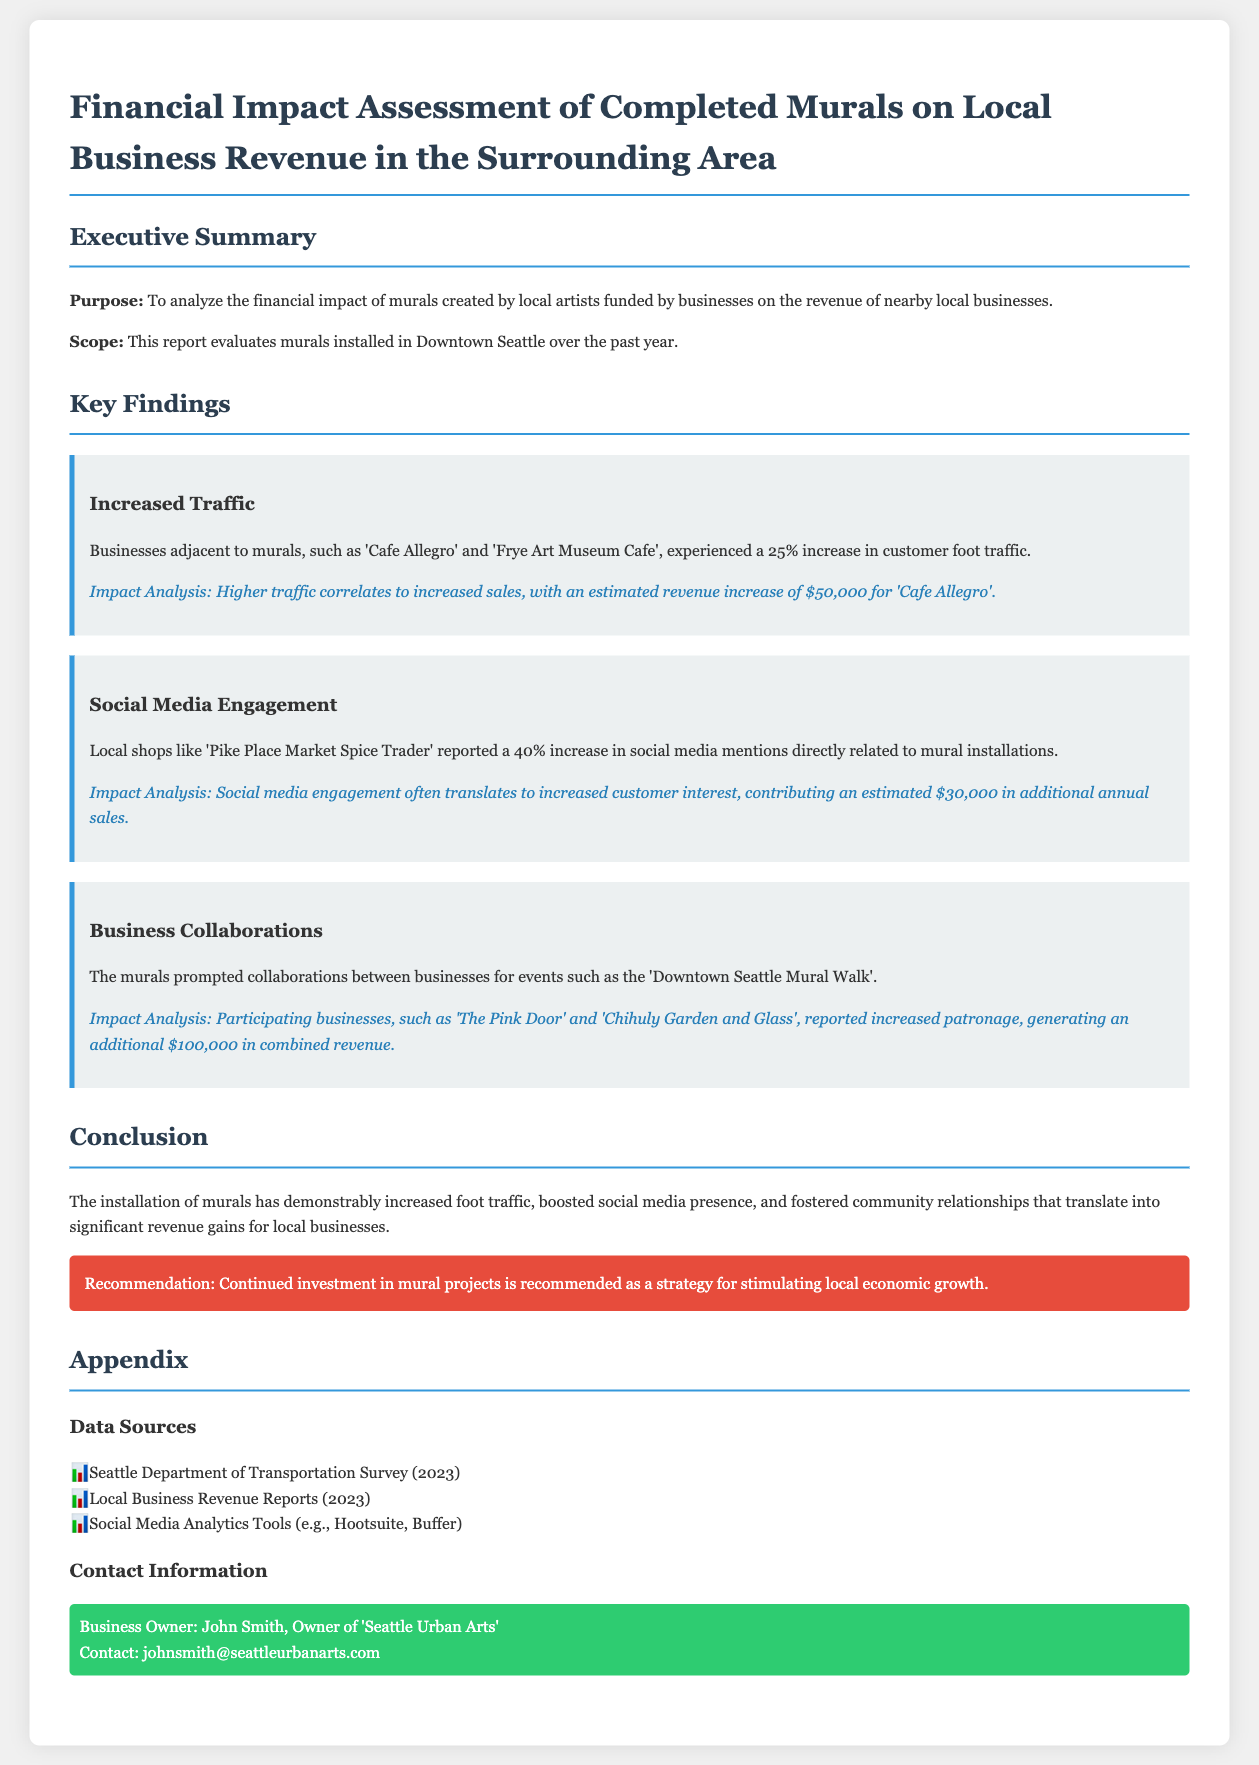What is the purpose of the report? The purpose is to analyze the financial impact of murals created by local artists funded by businesses on the revenue of nearby local businesses.
Answer: To analyze the financial impact of murals What was the increase in foot traffic reported by businesses adjacent to murals? Businesses adjacent to murals experienced a 25% increase in customer foot traffic.
Answer: 25% Which business reported an estimated revenue increase of $50,000? The document states that 'Cafe Allegro' had an estimated revenue increase of $50,000 due to higher foot traffic.
Answer: Cafe Allegro What is the estimated additional annual sales attributed to increased social media mentions? The report mentions an estimated $30,000 in additional annual sales linked to social media engagement.
Answer: $30,000 What is the total combined revenue generation from businesses participating in the mural walk? The participating businesses reported a combined revenue of $100,000 due to increased patronage from the mural walk.
Answer: $100,000 What recommendation is provided in the conclusion? The recommendation emphasizes continued investment in mural projects to stimulate local economic growth.
Answer: Continued investment in mural projects Which local shops saw a 40% increase in social media mentions? The report specifically mentions 'Pike Place Market Spice Trader' reported the increase.
Answer: Pike Place Market Spice Trader What year are the data sources from? The data sources listed in the appendix are from the year 2023.
Answer: 2023 